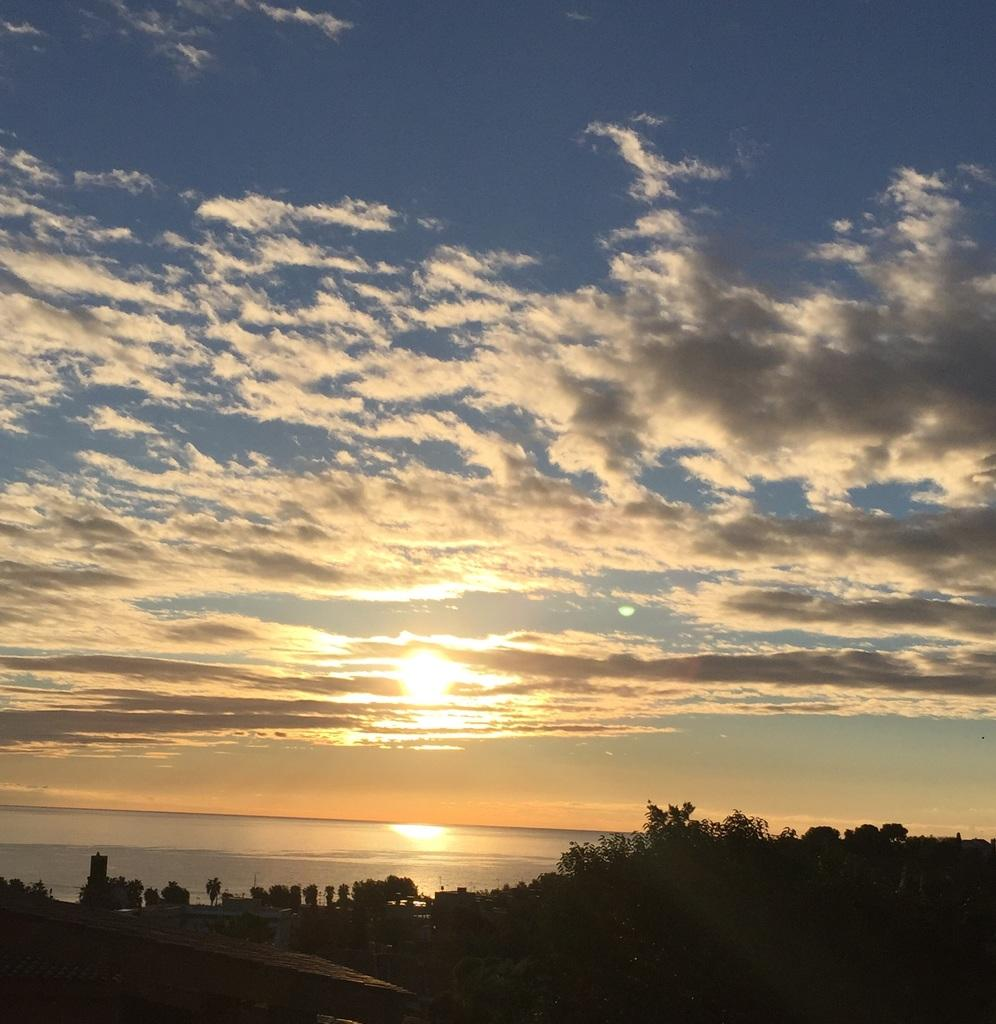What time of day is depicted in the image? The image depicts a sunset, which typically occurs in the evening. What is the condition of the sky in the image? The sky is cloudy in the image. What type of natural environment can be seen in the image? There are trees visible in the image, which suggests a forest or wooded area. What is the presence of water in the image indicative of? The presence of water in the image could suggest a lake, river, or other body of water nearby. What type of plantation can be seen in the image? There is no plantation present in the image; it depicts a sunset with a cloudy sky, trees, and water. How many kittens are playing in the water in the image? There are no kittens present in the image; it features a sunset with a cloudy sky, trees, and water. 